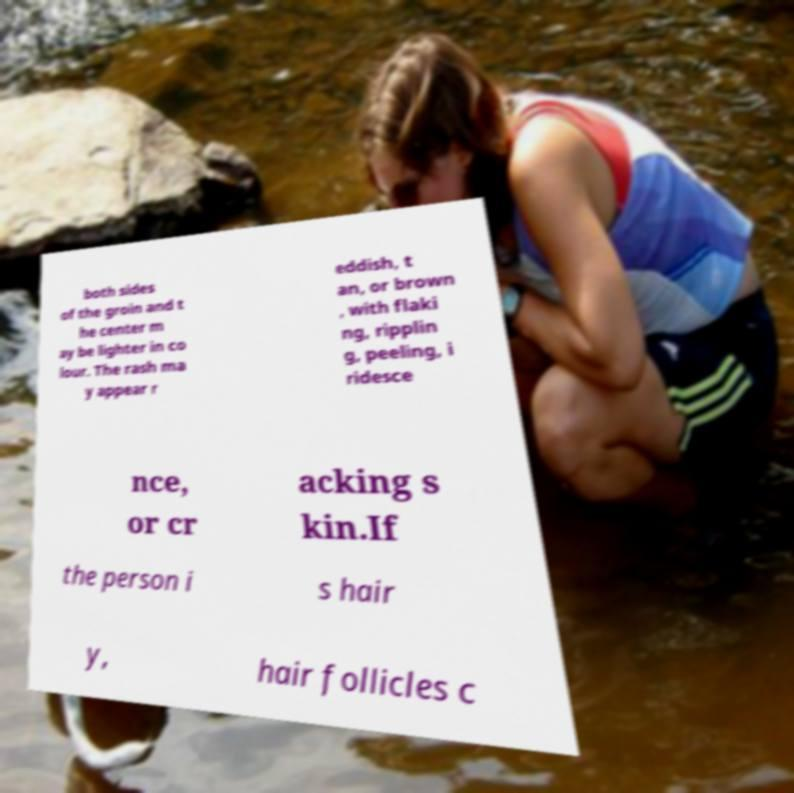Can you accurately transcribe the text from the provided image for me? both sides of the groin and t he center m ay be lighter in co lour. The rash ma y appear r eddish, t an, or brown , with flaki ng, ripplin g, peeling, i ridesce nce, or cr acking s kin.If the person i s hair y, hair follicles c 